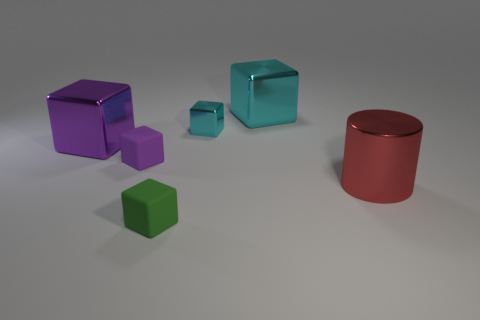Subtract all small cyan cubes. How many cubes are left? 4 Subtract all yellow blocks. Subtract all blue spheres. How many blocks are left? 5 Add 2 green matte objects. How many objects exist? 8 Subtract all cylinders. How many objects are left? 5 Subtract 1 red cylinders. How many objects are left? 5 Subtract all things. Subtract all small yellow shiny cylinders. How many objects are left? 0 Add 3 shiny objects. How many shiny objects are left? 7 Add 4 small purple blocks. How many small purple blocks exist? 5 